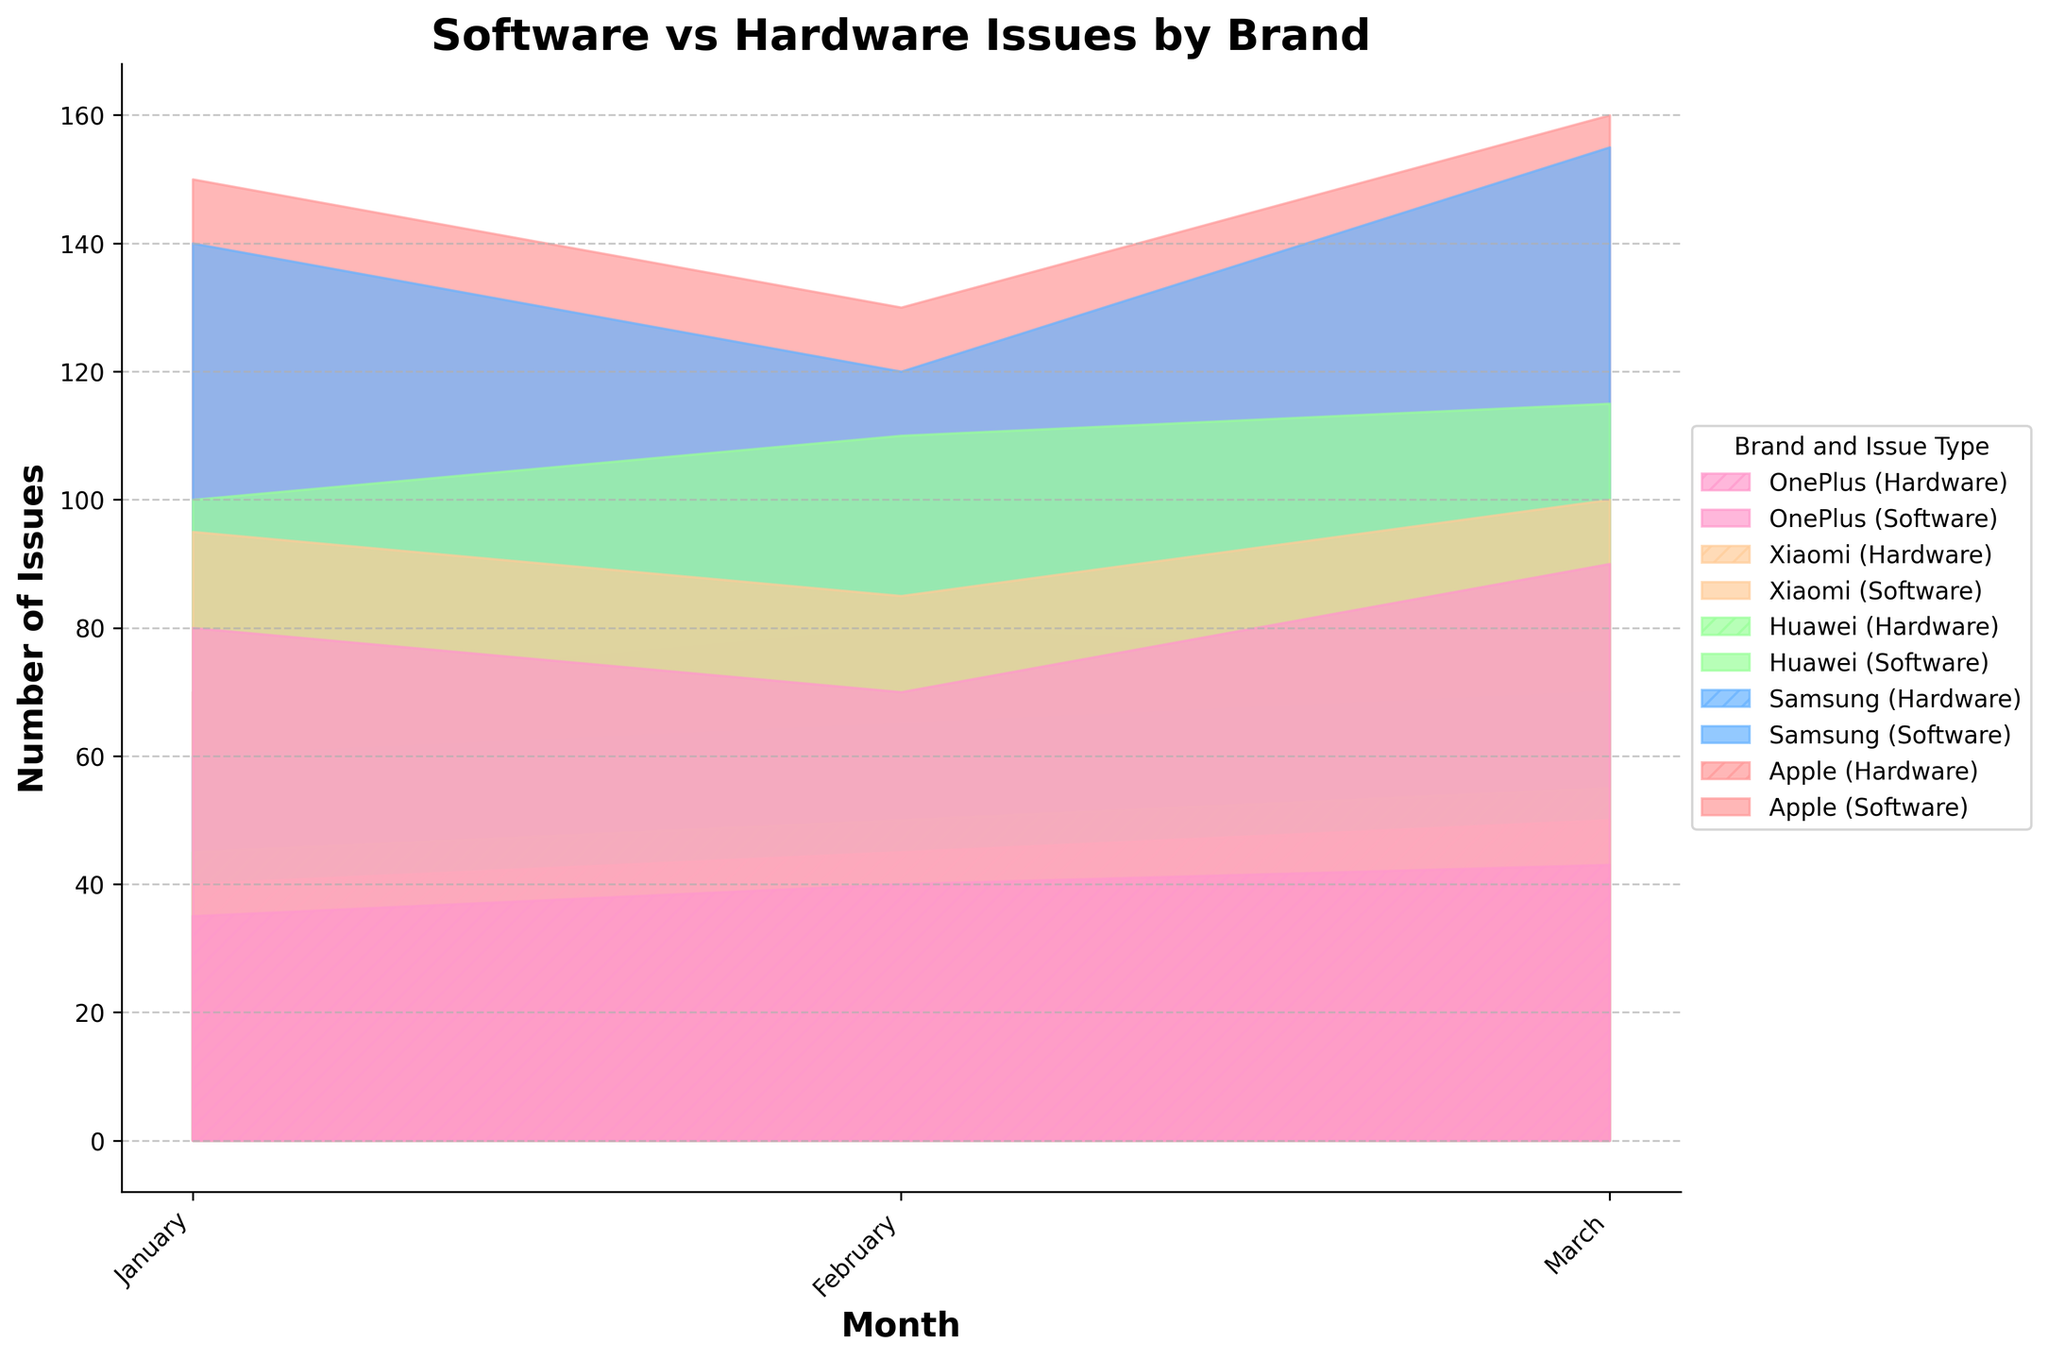What's the title of the chart? The title of the chart is typically displayed at the top of the figure. Here, the title provided is "Software vs Hardware Issues by Brand".
Answer: Software vs Hardware Issues by Brand What are the labels of the x-axis and y-axis? The labels are commonly noted at the ends of the respective axes. For this chart, the x-axis is labeled "Month" and the y-axis is labeled "Number of Issues".
Answer: Month, Number of Issues Which mobile phone brand experienced the most software issues in March? To answer this, locate March on the x-axis and identify the highest point among the filled areas corresponding to software issues for each brand. Apple has the highest value in this month.
Answer: Apple How does the number of hardware issues for Xiaomi change from January to March? Identify Xiaomi's hardware issues for January, February, and March on the chart. In January, there are 40 issues, in February 45 issues, and in March it increases to 50 issues.
Answer: It increases from 40 to 50 Which brand has fewer hardware issues in January, Samsung or Huawei? Compare the hardware issue levels for Samsung and Huawei in January. Samsung has 60 hardware issues, while Huawei has 45 hardware issues.
Answer: Huawei What is the total number of software issues for Apple over the three months? Sum the software issues for Apple in January, February, and March. The values are 150, 130, and 160 respectively, so the total is 150 + 130 + 160.
Answer: 440 What month saw the highest number of total hardware issues? Sum the hardware issues for all brands in each month and compare. January: 70 + 60 + 45 + 40 + 35 = 250, February: 80 + 65 + 50 + 45 + 40 = 280, March: 75 + 70 + 55 + 50 + 43 = 293. March has the highest total.
Answer: March How does the number of software issues for Huawei compare to OnePlus in February? Locate February and compare the heights of the areas filled for Huawei and OnePlus. Huawei has 110 software issues and OnePlus has 70.
Answer: Huawei is higher What’s the difference in software issues between Samsung and Apple in March? Identify the software issues for both brands in March. Apple has 160 and Samsung has 155. Subtract Samsung's from Apple's.
Answer: 5 Which brand shows a declining trend in software issues over the three months? Analyze each brand's software issues from January to March. Only Xiaomi shows a consistent decline (95 to 85 to 100).
Answer: None 